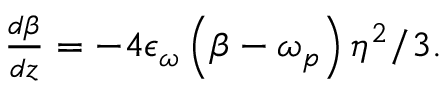<formula> <loc_0><loc_0><loc_500><loc_500>\begin{array} { r l r } { \frac { d \beta } { d z } = - 4 \epsilon _ { \omega } \left ( \beta - \omega _ { p } \right ) \eta ^ { 2 } / 3 . } \end{array}</formula> 